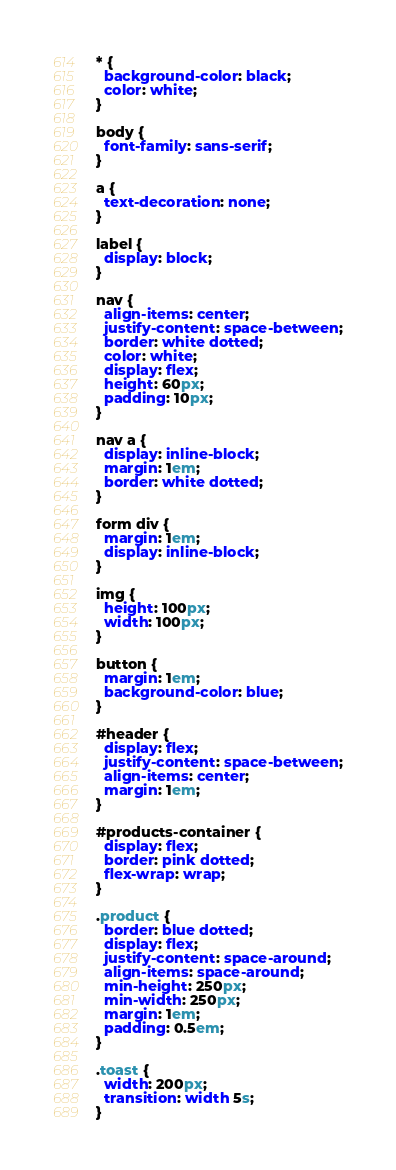<code> <loc_0><loc_0><loc_500><loc_500><_CSS_>* {
  background-color: black;
  color: white;
}

body {
  font-family: sans-serif;
}

a {
  text-decoration: none;
}

label {
  display: block;
}

nav {
  align-items: center;
  justify-content: space-between;
  border: white dotted;
  color: white;
  display: flex;
  height: 60px;
  padding: 10px;
}

nav a {
  display: inline-block;
  margin: 1em;
  border: white dotted;
}

form div {
  margin: 1em;
  display: inline-block;
}

img {
  height: 100px;
  width: 100px;
}

button {
  margin: 1em;
  background-color: blue;
}

#header {
  display: flex;
  justify-content: space-between;
  align-items: center;
  margin: 1em;
}

#products-container {
  display: flex;
  border: pink dotted;
  flex-wrap: wrap;
}

.product {
  border: blue dotted;
  display: flex;
  justify-content: space-around;
  align-items: space-around;
  min-height: 250px;
  min-width: 250px;
  margin: 1em;
  padding: 0.5em;
}

.toast {
  width: 200px;
  transition: width 5s;
}
</code> 